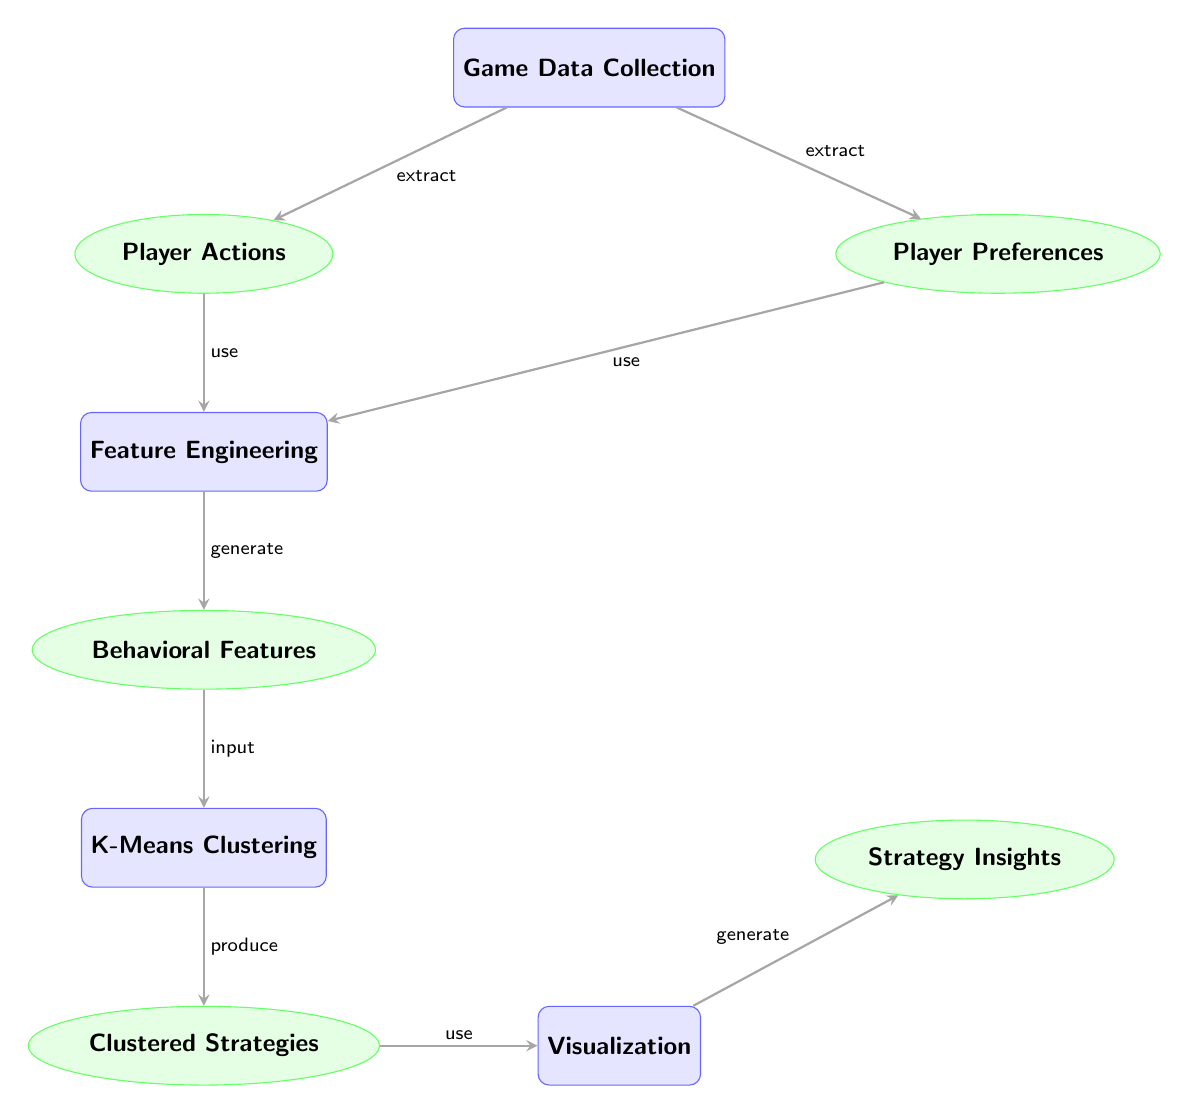What are the two types of data collected from the game? The two types of data collected from the game are represented by the nodes labeled "Player Actions" and "Player Preferences." These are directly connected to the node "Game Data Collection."
Answer: Player Actions, Player Preferences How many processes are there in the diagram? By counting the nodes designated as processes, we see that there are four processes: "Game Data Collection," "Feature Engineering," "K-Means Clustering," and "Visualization."
Answer: 4 What is the output of the "K-Means Clustering" process? The process "K-Means Clustering" produces "Clustered Strategies" as shown by the arrow leading from it to that node, indicating what that process generates.
Answer: Clustered Strategies Which nodes use "Player Actions" as input? "Player Actions" is used as input by the "Feature Engineering" node, as shown by the arrow directed toward it, indicating the flow of information from "Player Actions" to "Feature Engineering."
Answer: Feature Engineering What is the final output generated from the diagram? The final output generated from the diagram is represented in the node "Strategy Insights," which is the end point of the process flow indicated by the arrows leading through the different processes.
Answer: Strategy Insights Which two processes are connected to the "Feature Engineering" node? The "Feature Engineering" node is connected to two processes, indicated by arrows coming from both "Player Actions" and "Player Preferences," showing that these inputs are utilized to generate features.
Answer: Player Actions, Player Preferences What type of clustering method is used in this diagram? The diagram specifies the use of "K-Means Clustering" as the clustering method employed in the analysis of player behavior.
Answer: K-Means Clustering Which node represents data generated from feature engineering? The node that directly follows "Feature Engineering" in the diagram is labeled "Behavioral Features," which highlights the data produced as a result of that process.
Answer: Behavioral Features 